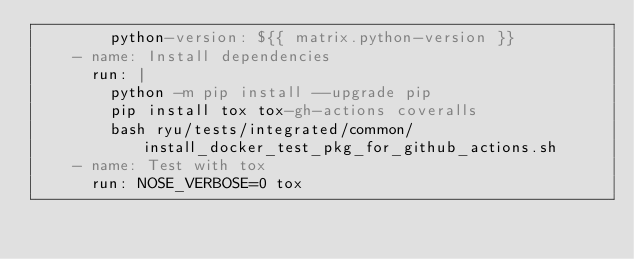Convert code to text. <code><loc_0><loc_0><loc_500><loc_500><_YAML_>        python-version: ${{ matrix.python-version }}
    - name: Install dependencies
      run: |
        python -m pip install --upgrade pip
        pip install tox tox-gh-actions coveralls
        bash ryu/tests/integrated/common/install_docker_test_pkg_for_github_actions.sh
    - name: Test with tox
      run: NOSE_VERBOSE=0 tox
</code> 